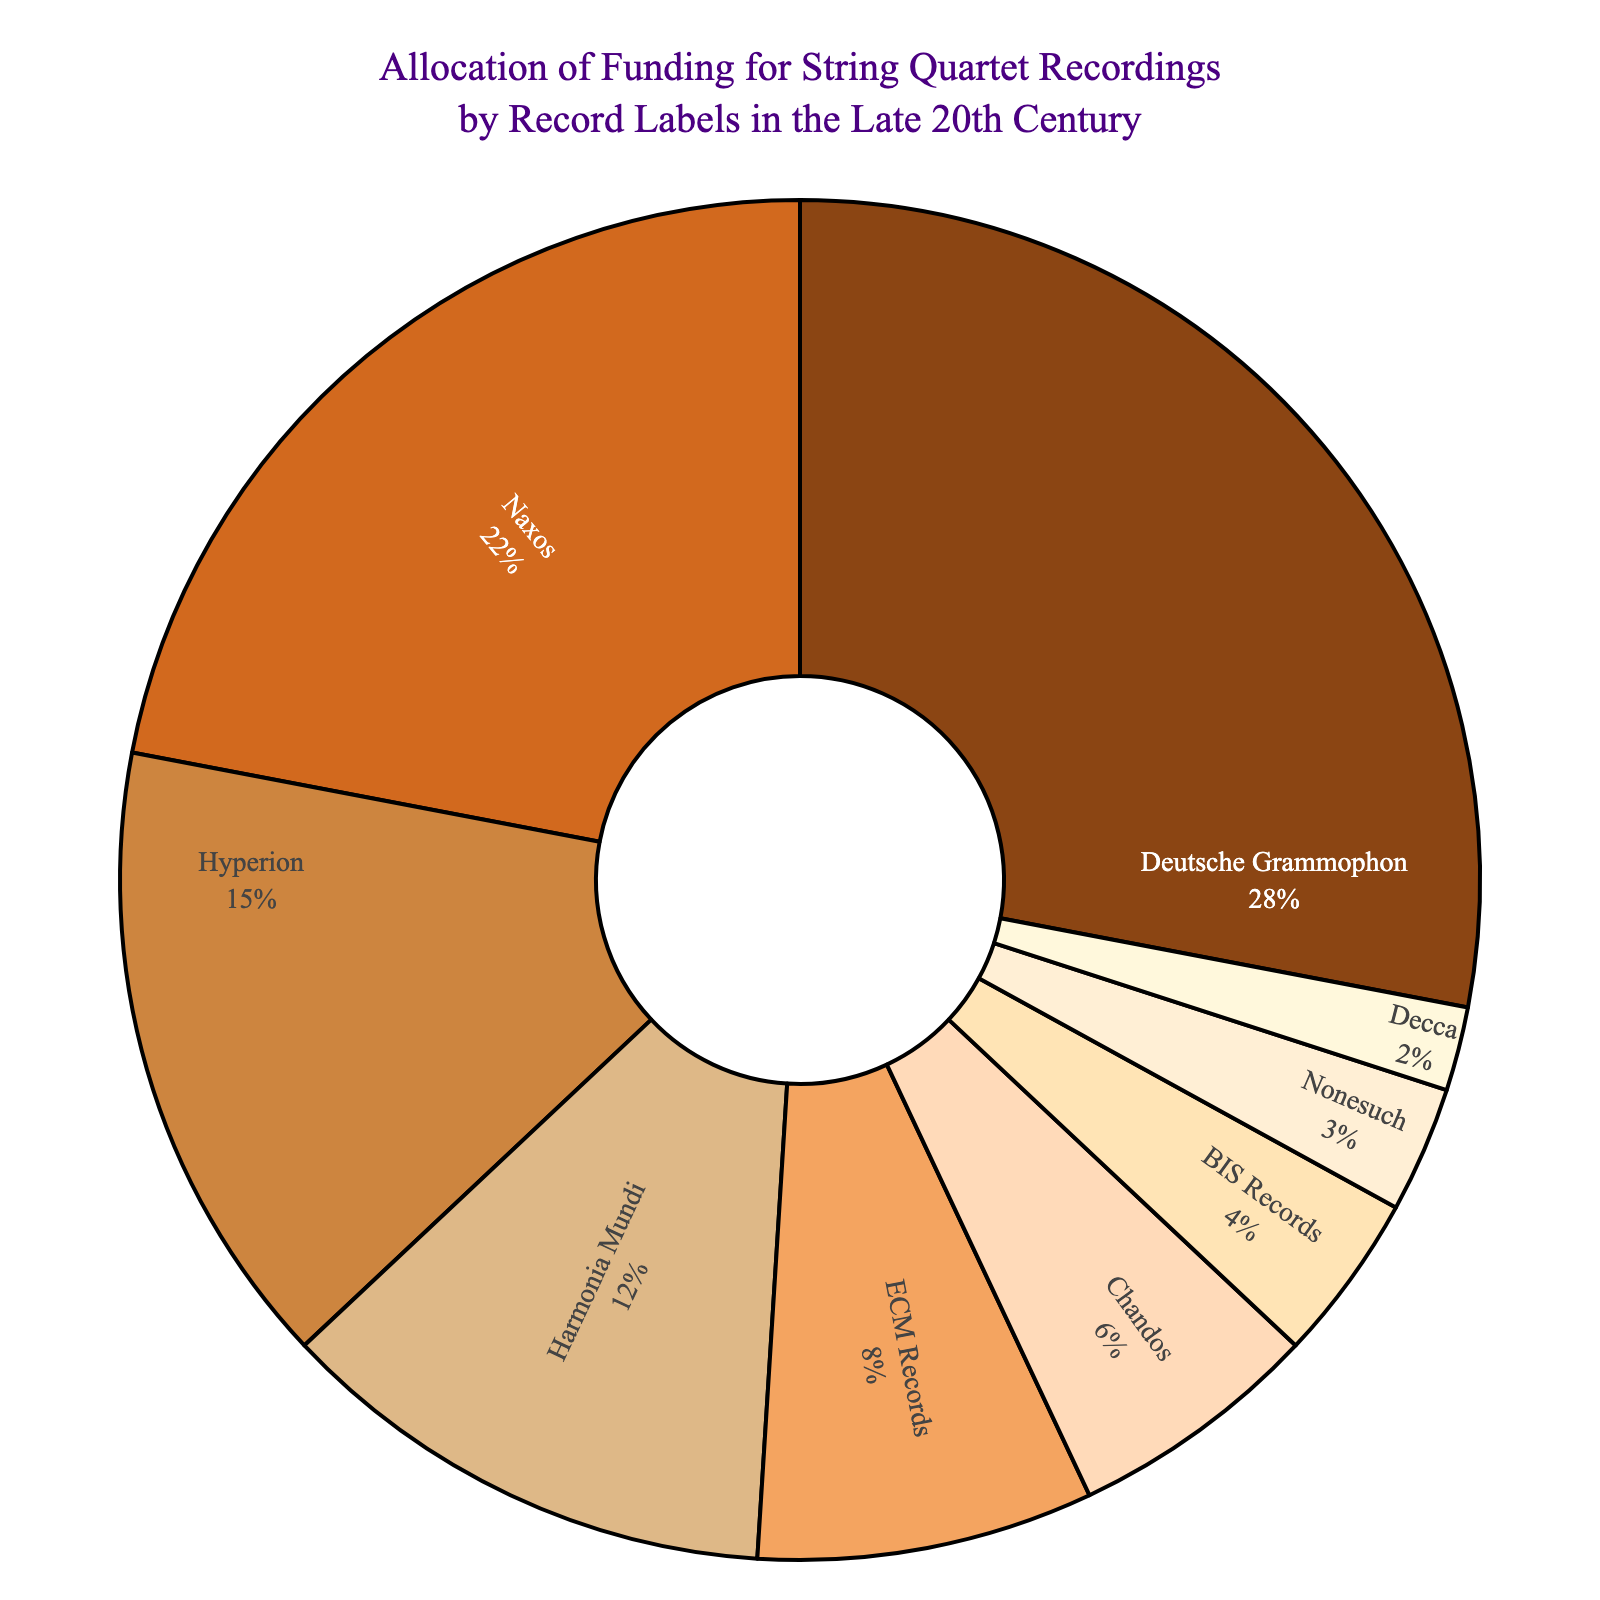Which record label received the highest percentage of funding? By looking at the pie chart, we see that Deutsche Grammophon has the largest portion.
Answer: Deutsche Grammophon Which two record labels received almost the same amount of funding? By comparing the sizes of the pie sections, Harmonia Mundi (12%) and ECM Records (8%) seem close, but a closer match is Chandos (6%) and BIS Records (4%) as their percentages are the closest.
Answer: Chandos and BIS Records What is the combined funding percentage for Deutsche Grammophon and Naxos? Deutsche Grammophon has 28% and Naxos has 22%. Summing these gives 28% + 22% = 50%.
Answer: 50% How much more funding did Hyperion receive compared to Decca? Hyperion received 15% and Decca received 2%. The difference is 15% - 2% = 13%.
Answer: 13% What is the average funding percentage for Hyperion, Harmonia Mundi, and ECM Records? Add the percentages: 15% + 12% + 8% = 35%. Then, divide by the number of labels: 35% / 3 ≈ 11.67%.
Answer: 11.67% Which record label received the least funding? By looking at the smallest slice in the pie chart, we see that Decca received the least funding.
Answer: Decca Are the combined percentages of Hyperion and Harmonia Mundi greater than the percentage of Naxos? Hyperion has 15% and Harmonia Mundi has 12%, giving a total of 15% + 12% = 27%, which is less than Naxos's 22%.
Answer: No How many record labels received more than 10% of the funding? Deutsche Grammophon, Naxos, and Hyperion each received more than 10%. In total, there are 3 labels.
Answer: 3 What is the difference in funding percentage between the highest-funded and lowest-funded labels? Deutsche Grammophon has the highest funding at 28%, and Decca has the lowest at 2%. The difference is 28% - 2% = 26%.
Answer: 26% If we combine the funding percentage for the smallest three labels, how does it compare to the funding of Naxos? The smallest three labels are Decca (2%), Nonesuch (3%), and BIS Records (4%). Combined, they have 2% + 3% + 4% = 9%. Naxos has 22%, which is greater than the combined 9%.
Answer: Naxos has more 